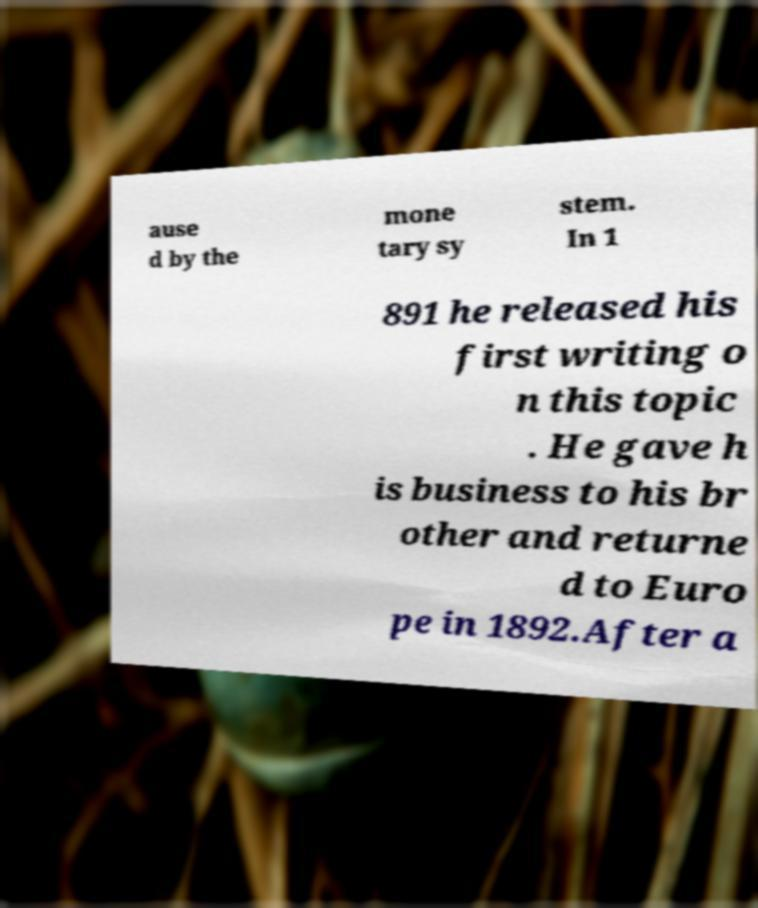Could you assist in decoding the text presented in this image and type it out clearly? ause d by the mone tary sy stem. In 1 891 he released his first writing o n this topic . He gave h is business to his br other and returne d to Euro pe in 1892.After a 